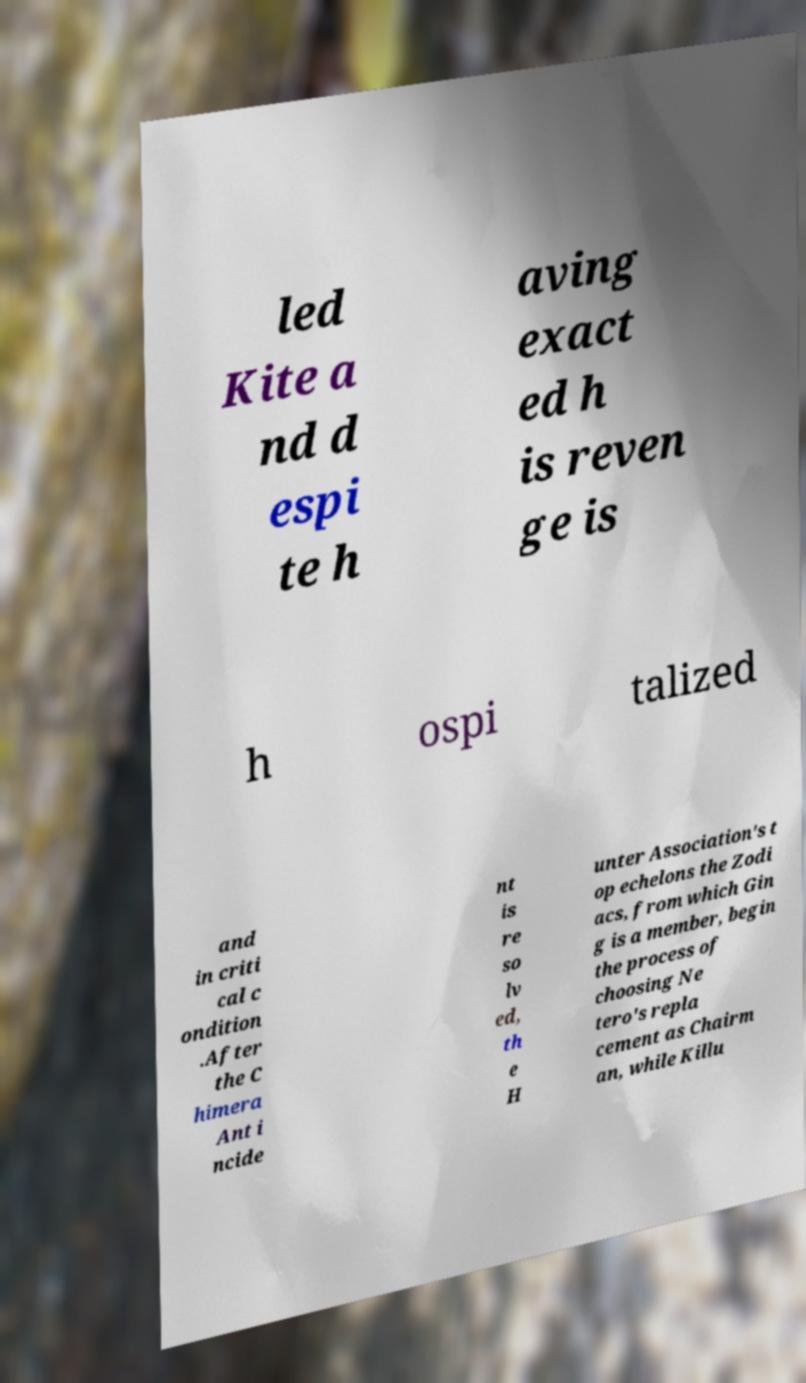What messages or text are displayed in this image? I need them in a readable, typed format. led Kite a nd d espi te h aving exact ed h is reven ge is h ospi talized and in criti cal c ondition .After the C himera Ant i ncide nt is re so lv ed, th e H unter Association's t op echelons the Zodi acs, from which Gin g is a member, begin the process of choosing Ne tero's repla cement as Chairm an, while Killu 